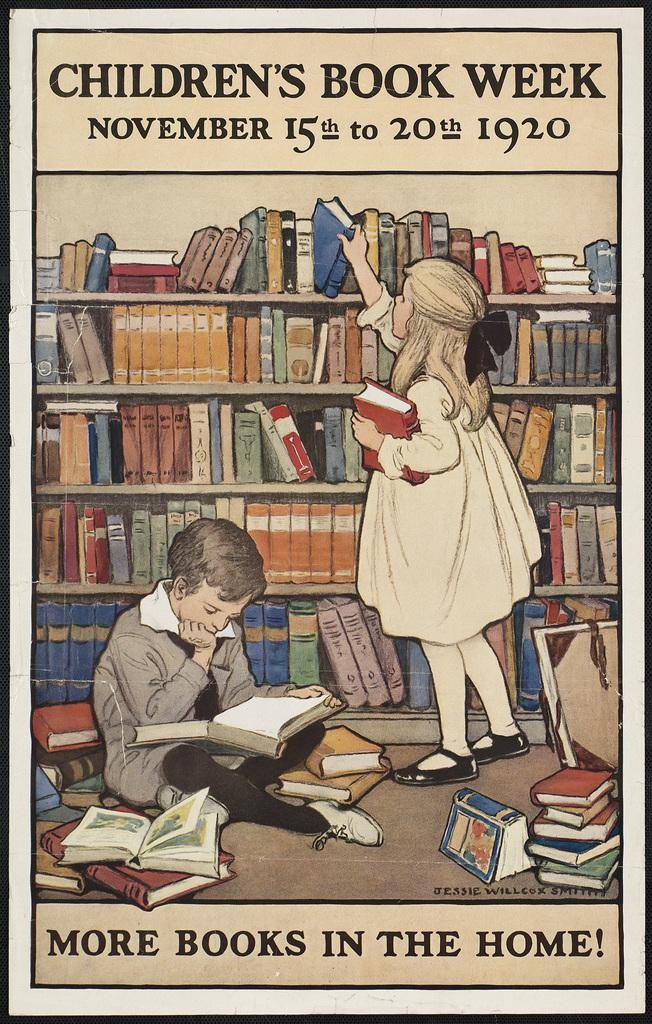<image>
Offer a succinct explanation of the picture presented. a poster that says children's book week on it 